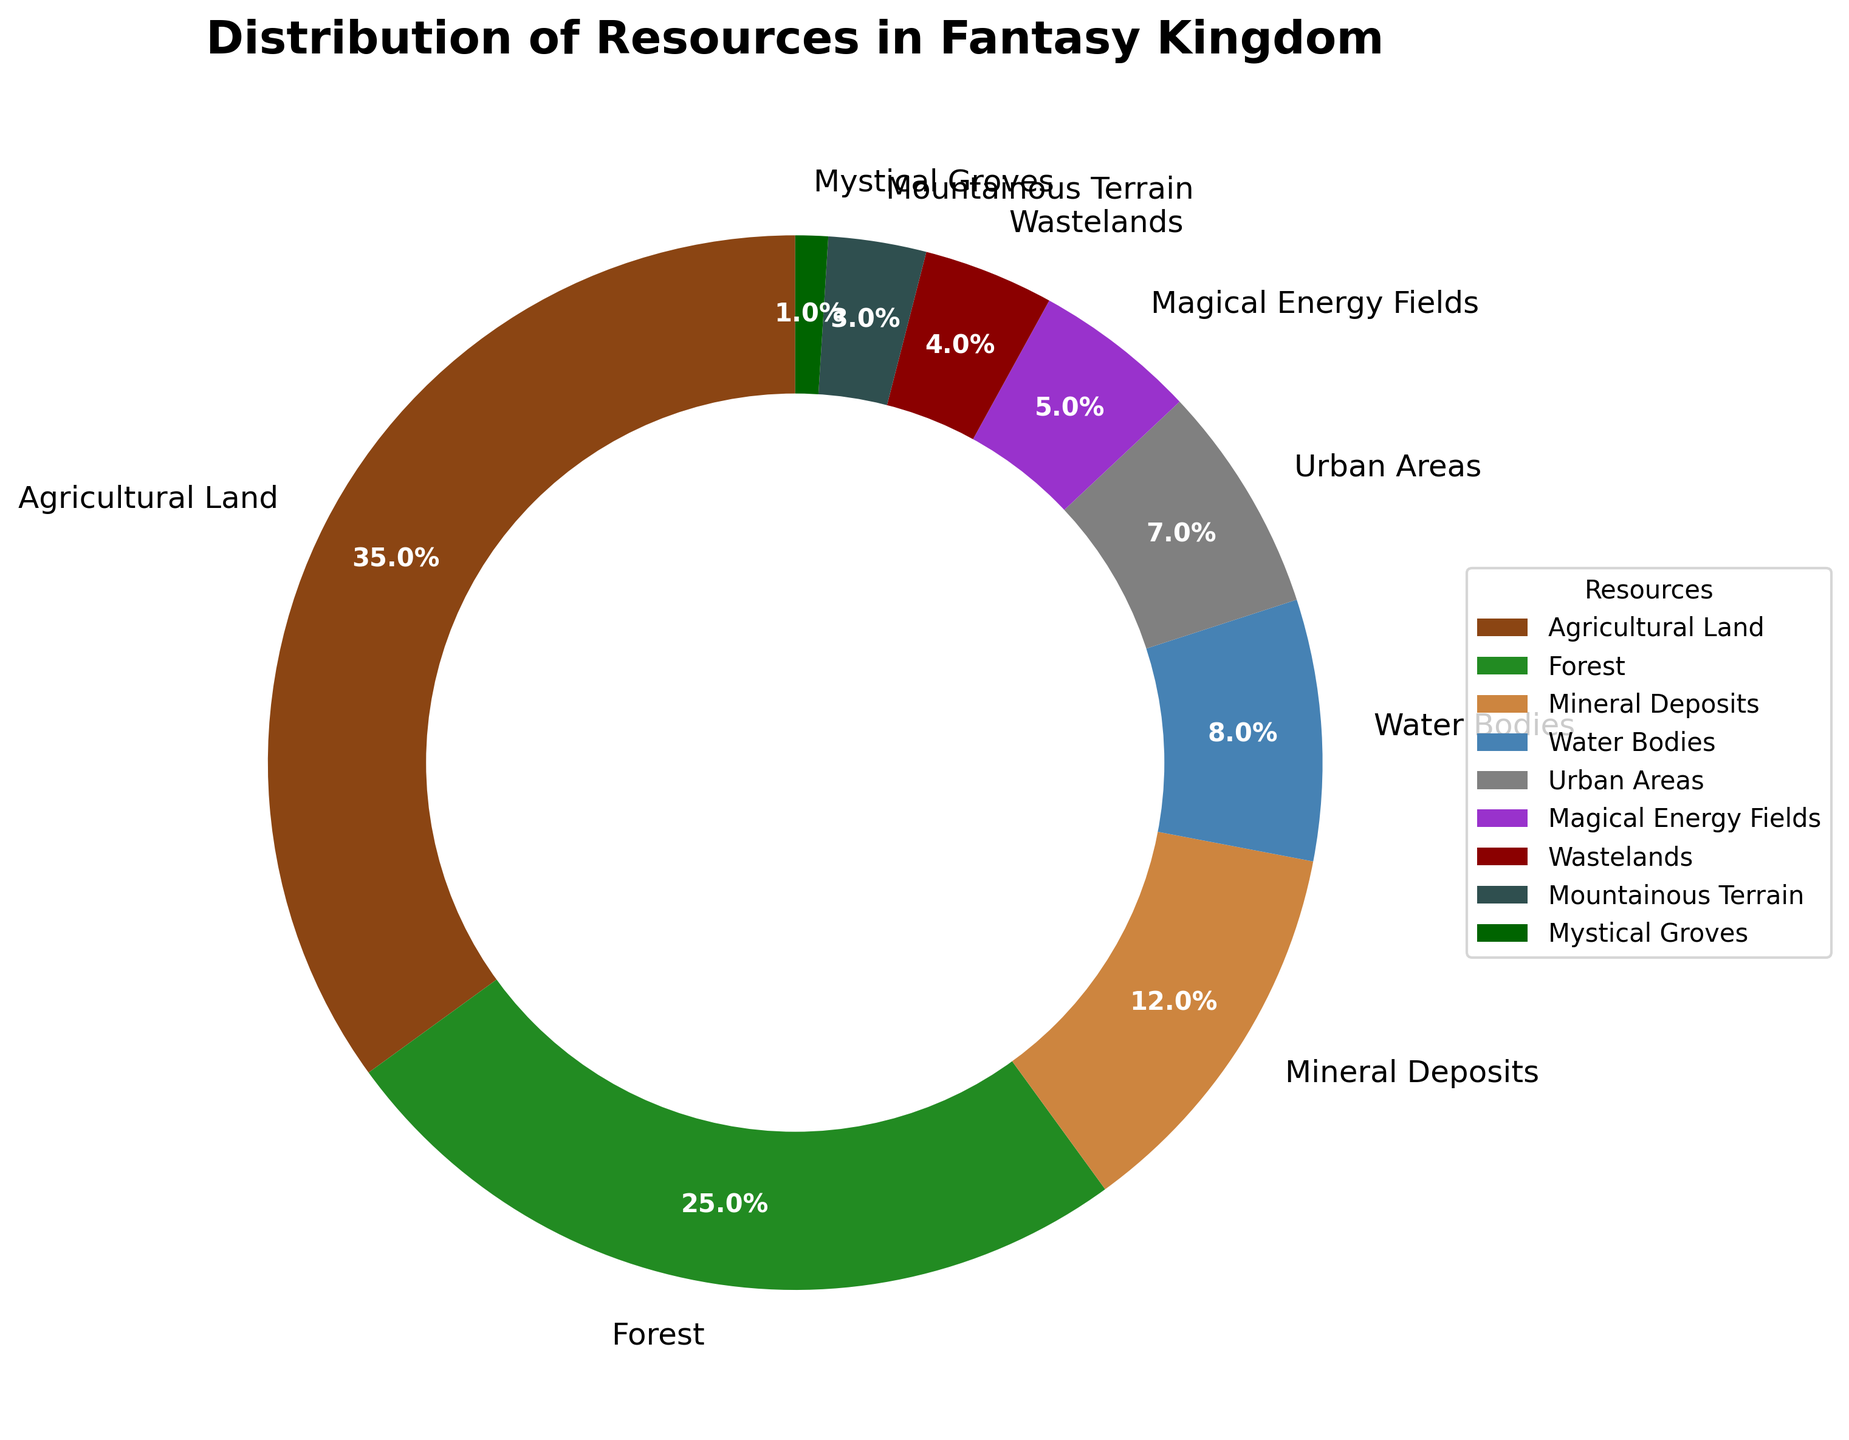What percentage of the kingdom is covered by forests and mineral deposits combined? To find the combined percentage of forests and mineral deposits, sum their individual percentages: 25% (forests) + 12% (mineral deposits). This results in 37%.
Answer: 37% Is the percentage of urban areas greater than or less than the percentage of water bodies? The percentage of urban areas (7%) is less than the percentage of water bodies (8%).
Answer: Less than Which resource takes up the largest portion of the kingdom's land? By comparing the percentages, agricultural land has the largest portion at 35%.
Answer: Agricultural Land What is the difference in the percentage coverage between agricultural land and magical energy fields? To find the difference, subtract the percentage of magical energy fields (5%) from the percentage of agricultural land (35%). The difference is 30%.
Answer: 30% How does the combined percentage of wastelands and mystical groves compare to the coverage of urban areas? Sum the percentages of wastelands (4%) and mystical groves (1%) to get 5%. This combined percentage is less than the percentage of urban areas (7%).
Answer: Less than What resource has the third highest percentage coverage in the kingdom? By ordering the percentages in descending order, the third-highest percentage is for mineral deposits at 12%.
Answer: Mineral Deposits What is the total percentage of resources covered by mountain terrain, wastelands, and mystical groves? Sum the percentages of mountainous terrain (3%), wastelands (4%), and mystical groves (1%). The total is 3% + 4% + 1% = 8%.
Answer: 8% How much more percentage of the kingdom is covered by agricultural land compared to forests? Subtract the percentage of forests (25%) from the percentage of agricultural land (35%). The difference is 10%.
Answer: 10% Can we categorize the resources covered by less than 10%? The resources with less than 10% coverage are water bodies (8%), urban areas (7%), magical energy fields (5%), wastelands (4%), mountainous terrain (3%), and mystical groves (1%).
Answer: Water bodies, Urban areas, Magical energy fields, Wastelands, Mountainous terrain, Mystical groves Which resource is depicted in dark green and what is its percentage? The dark green color in the pie chart represents the forest which covers 25% of the kingdom.
Answer: Forest, 25% 